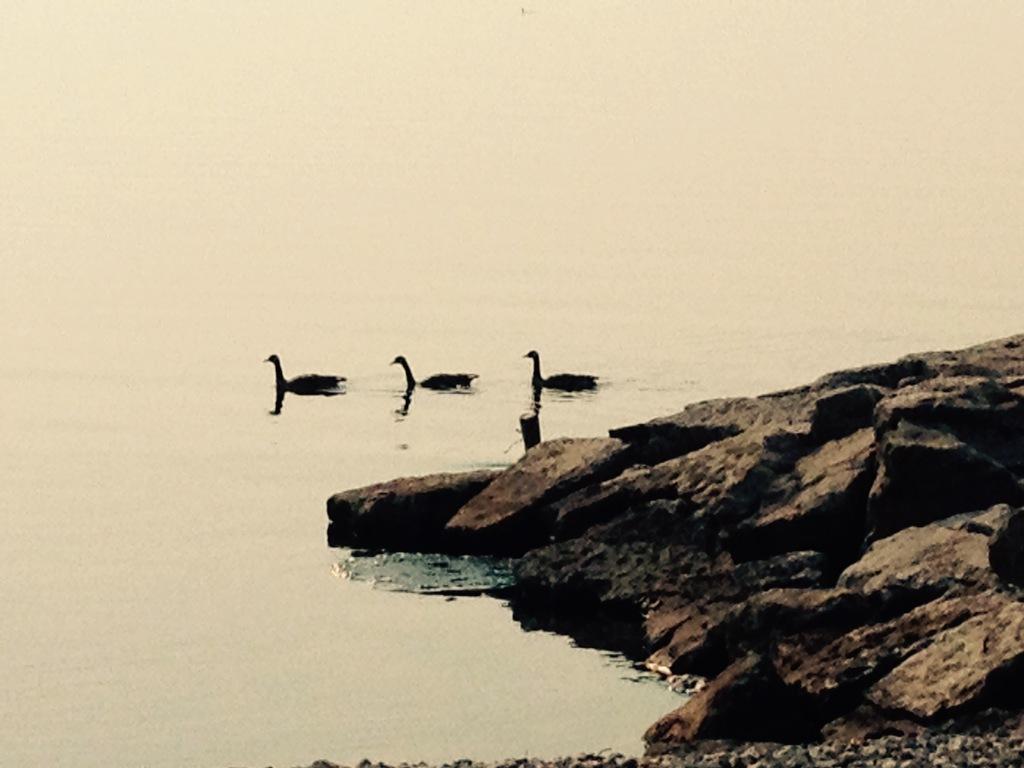Describe this image in one or two sentences. In the image we can see three birds in the water. This is a water and stones. 